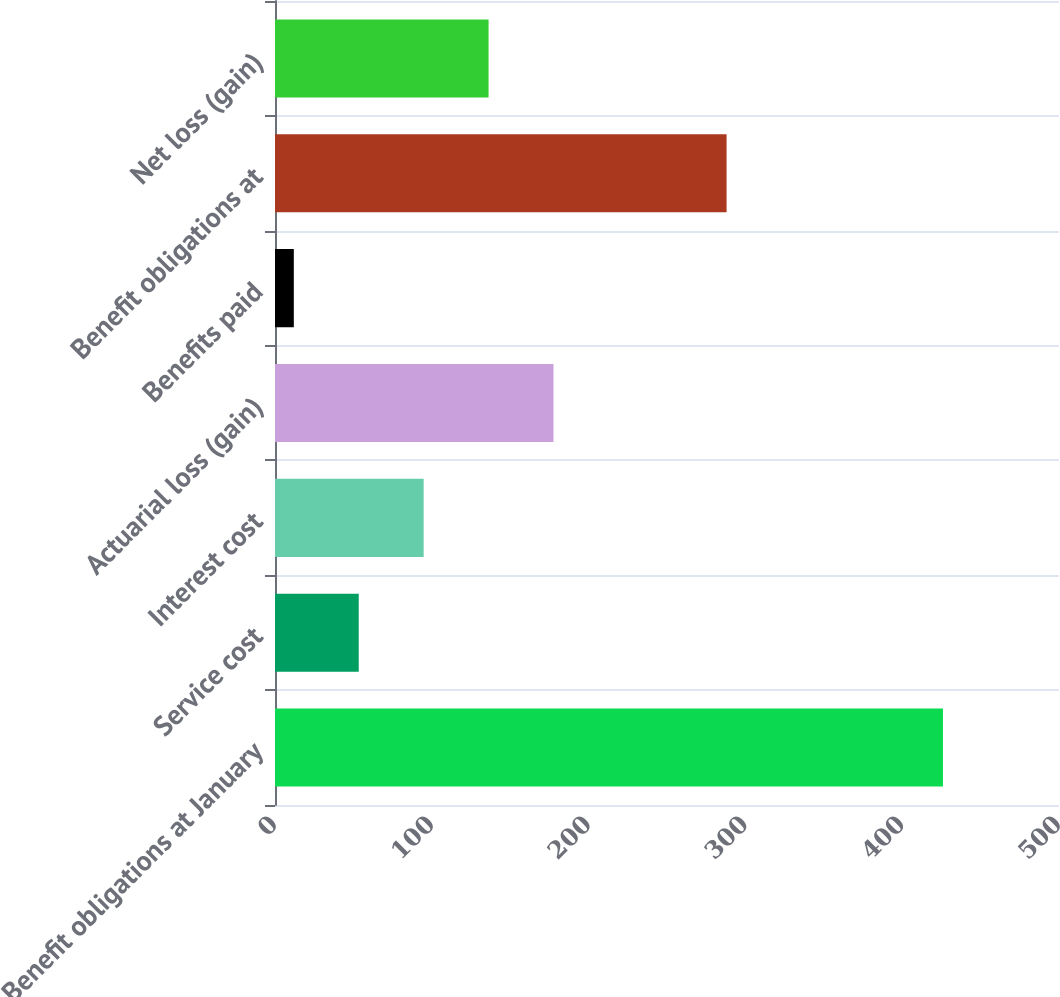Convert chart to OTSL. <chart><loc_0><loc_0><loc_500><loc_500><bar_chart><fcel>Benefit obligations at January<fcel>Service cost<fcel>Interest cost<fcel>Actuarial loss (gain)<fcel>Benefits paid<fcel>Benefit obligations at<fcel>Net loss (gain)<nl><fcel>426<fcel>53.4<fcel>94.8<fcel>177.6<fcel>12<fcel>288<fcel>136.2<nl></chart> 